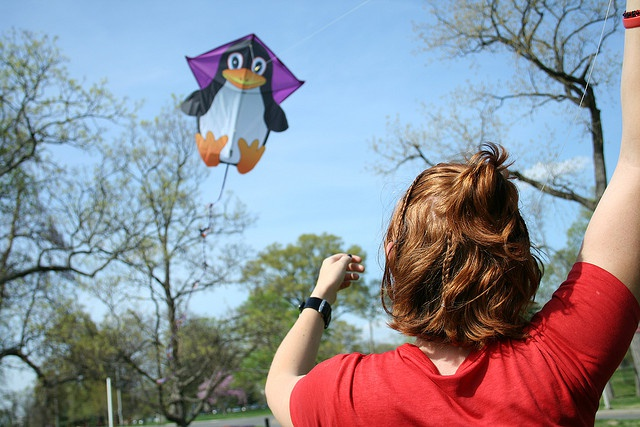Describe the objects in this image and their specific colors. I can see people in lightblue, black, red, maroon, and salmon tones, kite in lightblue, black, and brown tones, and clock in lightblue, black, gray, and navy tones in this image. 